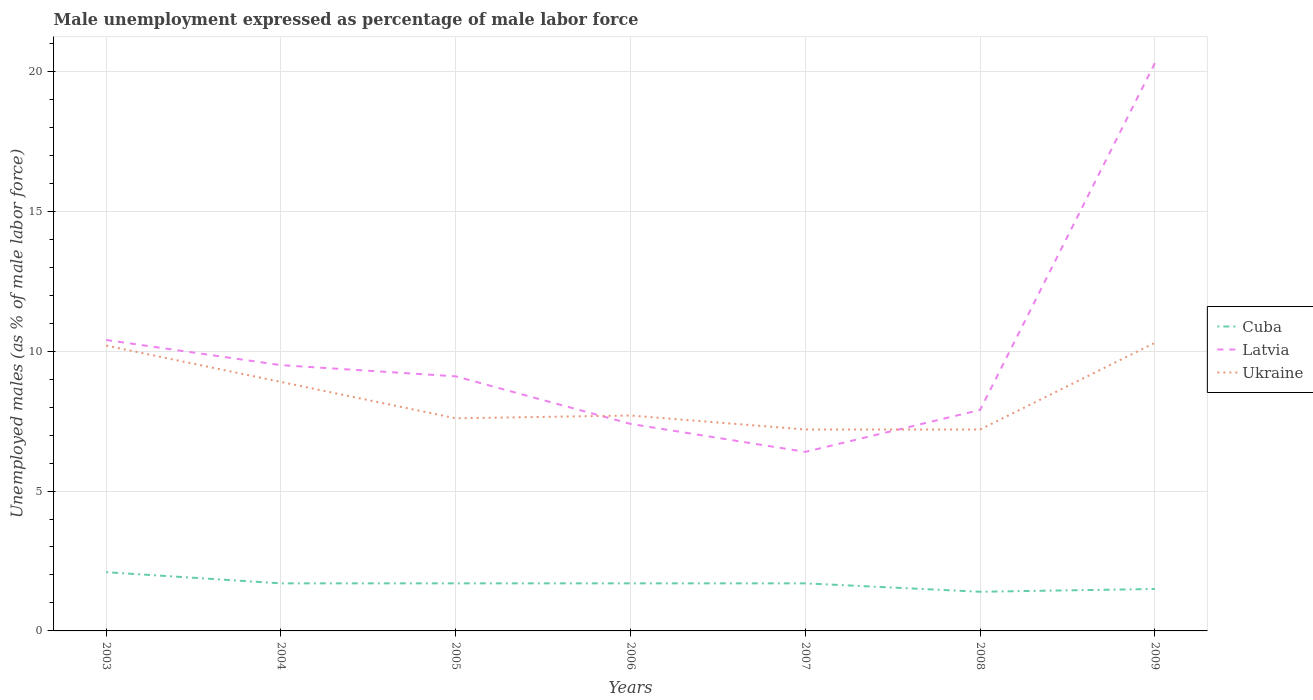Does the line corresponding to Cuba intersect with the line corresponding to Latvia?
Offer a terse response. No. Across all years, what is the maximum unemployment in males in in Ukraine?
Keep it short and to the point. 7.2. What is the total unemployment in males in in Latvia in the graph?
Keep it short and to the point. 1. What is the difference between the highest and the second highest unemployment in males in in Latvia?
Give a very brief answer. 13.9. How many lines are there?
Offer a very short reply. 3. Are the values on the major ticks of Y-axis written in scientific E-notation?
Provide a short and direct response. No. Where does the legend appear in the graph?
Offer a terse response. Center right. How many legend labels are there?
Your answer should be very brief. 3. How are the legend labels stacked?
Your answer should be compact. Vertical. What is the title of the graph?
Your answer should be very brief. Male unemployment expressed as percentage of male labor force. Does "Chile" appear as one of the legend labels in the graph?
Ensure brevity in your answer.  No. What is the label or title of the X-axis?
Offer a terse response. Years. What is the label or title of the Y-axis?
Offer a very short reply. Unemployed males (as % of male labor force). What is the Unemployed males (as % of male labor force) in Cuba in 2003?
Make the answer very short. 2.1. What is the Unemployed males (as % of male labor force) in Latvia in 2003?
Your answer should be very brief. 10.4. What is the Unemployed males (as % of male labor force) in Ukraine in 2003?
Offer a terse response. 10.2. What is the Unemployed males (as % of male labor force) of Cuba in 2004?
Your response must be concise. 1.7. What is the Unemployed males (as % of male labor force) in Ukraine in 2004?
Give a very brief answer. 8.9. What is the Unemployed males (as % of male labor force) of Cuba in 2005?
Provide a succinct answer. 1.7. What is the Unemployed males (as % of male labor force) in Latvia in 2005?
Your answer should be very brief. 9.1. What is the Unemployed males (as % of male labor force) in Ukraine in 2005?
Make the answer very short. 7.6. What is the Unemployed males (as % of male labor force) in Cuba in 2006?
Provide a short and direct response. 1.7. What is the Unemployed males (as % of male labor force) of Latvia in 2006?
Make the answer very short. 7.4. What is the Unemployed males (as % of male labor force) of Ukraine in 2006?
Offer a very short reply. 7.7. What is the Unemployed males (as % of male labor force) of Cuba in 2007?
Your response must be concise. 1.7. What is the Unemployed males (as % of male labor force) of Latvia in 2007?
Provide a succinct answer. 6.4. What is the Unemployed males (as % of male labor force) in Ukraine in 2007?
Offer a terse response. 7.2. What is the Unemployed males (as % of male labor force) of Cuba in 2008?
Your answer should be very brief. 1.4. What is the Unemployed males (as % of male labor force) of Latvia in 2008?
Your response must be concise. 7.9. What is the Unemployed males (as % of male labor force) in Ukraine in 2008?
Your answer should be very brief. 7.2. What is the Unemployed males (as % of male labor force) in Cuba in 2009?
Your answer should be compact. 1.5. What is the Unemployed males (as % of male labor force) in Latvia in 2009?
Ensure brevity in your answer.  20.3. What is the Unemployed males (as % of male labor force) in Ukraine in 2009?
Ensure brevity in your answer.  10.3. Across all years, what is the maximum Unemployed males (as % of male labor force) of Cuba?
Make the answer very short. 2.1. Across all years, what is the maximum Unemployed males (as % of male labor force) in Latvia?
Offer a very short reply. 20.3. Across all years, what is the maximum Unemployed males (as % of male labor force) of Ukraine?
Keep it short and to the point. 10.3. Across all years, what is the minimum Unemployed males (as % of male labor force) of Cuba?
Your response must be concise. 1.4. Across all years, what is the minimum Unemployed males (as % of male labor force) of Latvia?
Provide a succinct answer. 6.4. Across all years, what is the minimum Unemployed males (as % of male labor force) of Ukraine?
Provide a succinct answer. 7.2. What is the total Unemployed males (as % of male labor force) in Latvia in the graph?
Keep it short and to the point. 71. What is the total Unemployed males (as % of male labor force) in Ukraine in the graph?
Give a very brief answer. 59.1. What is the difference between the Unemployed males (as % of male labor force) in Ukraine in 2003 and that in 2004?
Your answer should be compact. 1.3. What is the difference between the Unemployed males (as % of male labor force) of Cuba in 2003 and that in 2005?
Your answer should be compact. 0.4. What is the difference between the Unemployed males (as % of male labor force) of Latvia in 2003 and that in 2005?
Your answer should be compact. 1.3. What is the difference between the Unemployed males (as % of male labor force) of Ukraine in 2003 and that in 2005?
Make the answer very short. 2.6. What is the difference between the Unemployed males (as % of male labor force) of Latvia in 2003 and that in 2006?
Your response must be concise. 3. What is the difference between the Unemployed males (as % of male labor force) in Latvia in 2003 and that in 2007?
Provide a succinct answer. 4. What is the difference between the Unemployed males (as % of male labor force) in Ukraine in 2003 and that in 2007?
Provide a succinct answer. 3. What is the difference between the Unemployed males (as % of male labor force) in Ukraine in 2003 and that in 2008?
Keep it short and to the point. 3. What is the difference between the Unemployed males (as % of male labor force) in Latvia in 2003 and that in 2009?
Your answer should be very brief. -9.9. What is the difference between the Unemployed males (as % of male labor force) in Ukraine in 2003 and that in 2009?
Give a very brief answer. -0.1. What is the difference between the Unemployed males (as % of male labor force) of Cuba in 2004 and that in 2005?
Give a very brief answer. 0. What is the difference between the Unemployed males (as % of male labor force) of Ukraine in 2004 and that in 2005?
Provide a succinct answer. 1.3. What is the difference between the Unemployed males (as % of male labor force) of Cuba in 2004 and that in 2006?
Ensure brevity in your answer.  0. What is the difference between the Unemployed males (as % of male labor force) of Cuba in 2004 and that in 2007?
Your answer should be compact. 0. What is the difference between the Unemployed males (as % of male labor force) of Ukraine in 2004 and that in 2007?
Offer a very short reply. 1.7. What is the difference between the Unemployed males (as % of male labor force) of Latvia in 2004 and that in 2008?
Provide a short and direct response. 1.6. What is the difference between the Unemployed males (as % of male labor force) in Cuba in 2004 and that in 2009?
Ensure brevity in your answer.  0.2. What is the difference between the Unemployed males (as % of male labor force) of Ukraine in 2004 and that in 2009?
Provide a short and direct response. -1.4. What is the difference between the Unemployed males (as % of male labor force) of Ukraine in 2005 and that in 2007?
Offer a terse response. 0.4. What is the difference between the Unemployed males (as % of male labor force) in Cuba in 2005 and that in 2008?
Make the answer very short. 0.3. What is the difference between the Unemployed males (as % of male labor force) in Latvia in 2005 and that in 2008?
Give a very brief answer. 1.2. What is the difference between the Unemployed males (as % of male labor force) in Ukraine in 2005 and that in 2008?
Provide a succinct answer. 0.4. What is the difference between the Unemployed males (as % of male labor force) of Cuba in 2005 and that in 2009?
Offer a very short reply. 0.2. What is the difference between the Unemployed males (as % of male labor force) in Ukraine in 2007 and that in 2008?
Offer a very short reply. 0. What is the difference between the Unemployed males (as % of male labor force) in Cuba in 2007 and that in 2009?
Your answer should be very brief. 0.2. What is the difference between the Unemployed males (as % of male labor force) of Latvia in 2007 and that in 2009?
Keep it short and to the point. -13.9. What is the difference between the Unemployed males (as % of male labor force) of Ukraine in 2007 and that in 2009?
Your answer should be very brief. -3.1. What is the difference between the Unemployed males (as % of male labor force) in Cuba in 2008 and that in 2009?
Your answer should be very brief. -0.1. What is the difference between the Unemployed males (as % of male labor force) in Latvia in 2008 and that in 2009?
Ensure brevity in your answer.  -12.4. What is the difference between the Unemployed males (as % of male labor force) in Latvia in 2003 and the Unemployed males (as % of male labor force) in Ukraine in 2004?
Provide a succinct answer. 1.5. What is the difference between the Unemployed males (as % of male labor force) of Latvia in 2003 and the Unemployed males (as % of male labor force) of Ukraine in 2005?
Give a very brief answer. 2.8. What is the difference between the Unemployed males (as % of male labor force) of Cuba in 2003 and the Unemployed males (as % of male labor force) of Latvia in 2006?
Keep it short and to the point. -5.3. What is the difference between the Unemployed males (as % of male labor force) in Cuba in 2003 and the Unemployed males (as % of male labor force) in Ukraine in 2006?
Your answer should be compact. -5.6. What is the difference between the Unemployed males (as % of male labor force) in Latvia in 2003 and the Unemployed males (as % of male labor force) in Ukraine in 2006?
Offer a terse response. 2.7. What is the difference between the Unemployed males (as % of male labor force) of Cuba in 2003 and the Unemployed males (as % of male labor force) of Latvia in 2008?
Make the answer very short. -5.8. What is the difference between the Unemployed males (as % of male labor force) of Cuba in 2003 and the Unemployed males (as % of male labor force) of Latvia in 2009?
Offer a terse response. -18.2. What is the difference between the Unemployed males (as % of male labor force) of Latvia in 2003 and the Unemployed males (as % of male labor force) of Ukraine in 2009?
Make the answer very short. 0.1. What is the difference between the Unemployed males (as % of male labor force) of Cuba in 2004 and the Unemployed males (as % of male labor force) of Ukraine in 2005?
Ensure brevity in your answer.  -5.9. What is the difference between the Unemployed males (as % of male labor force) of Latvia in 2004 and the Unemployed males (as % of male labor force) of Ukraine in 2005?
Your answer should be compact. 1.9. What is the difference between the Unemployed males (as % of male labor force) in Cuba in 2004 and the Unemployed males (as % of male labor force) in Latvia in 2006?
Provide a short and direct response. -5.7. What is the difference between the Unemployed males (as % of male labor force) in Latvia in 2004 and the Unemployed males (as % of male labor force) in Ukraine in 2007?
Give a very brief answer. 2.3. What is the difference between the Unemployed males (as % of male labor force) of Cuba in 2004 and the Unemployed males (as % of male labor force) of Latvia in 2008?
Keep it short and to the point. -6.2. What is the difference between the Unemployed males (as % of male labor force) in Cuba in 2004 and the Unemployed males (as % of male labor force) in Latvia in 2009?
Make the answer very short. -18.6. What is the difference between the Unemployed males (as % of male labor force) in Cuba in 2005 and the Unemployed males (as % of male labor force) in Latvia in 2006?
Provide a succinct answer. -5.7. What is the difference between the Unemployed males (as % of male labor force) of Latvia in 2005 and the Unemployed males (as % of male labor force) of Ukraine in 2006?
Your answer should be very brief. 1.4. What is the difference between the Unemployed males (as % of male labor force) in Cuba in 2005 and the Unemployed males (as % of male labor force) in Latvia in 2007?
Your answer should be compact. -4.7. What is the difference between the Unemployed males (as % of male labor force) of Cuba in 2005 and the Unemployed males (as % of male labor force) of Ukraine in 2007?
Give a very brief answer. -5.5. What is the difference between the Unemployed males (as % of male labor force) of Cuba in 2005 and the Unemployed males (as % of male labor force) of Latvia in 2008?
Provide a succinct answer. -6.2. What is the difference between the Unemployed males (as % of male labor force) of Cuba in 2005 and the Unemployed males (as % of male labor force) of Ukraine in 2008?
Your answer should be compact. -5.5. What is the difference between the Unemployed males (as % of male labor force) in Latvia in 2005 and the Unemployed males (as % of male labor force) in Ukraine in 2008?
Keep it short and to the point. 1.9. What is the difference between the Unemployed males (as % of male labor force) in Cuba in 2005 and the Unemployed males (as % of male labor force) in Latvia in 2009?
Provide a succinct answer. -18.6. What is the difference between the Unemployed males (as % of male labor force) of Latvia in 2005 and the Unemployed males (as % of male labor force) of Ukraine in 2009?
Provide a succinct answer. -1.2. What is the difference between the Unemployed males (as % of male labor force) of Cuba in 2006 and the Unemployed males (as % of male labor force) of Latvia in 2007?
Keep it short and to the point. -4.7. What is the difference between the Unemployed males (as % of male labor force) in Cuba in 2006 and the Unemployed males (as % of male labor force) in Ukraine in 2008?
Give a very brief answer. -5.5. What is the difference between the Unemployed males (as % of male labor force) in Cuba in 2006 and the Unemployed males (as % of male labor force) in Latvia in 2009?
Make the answer very short. -18.6. What is the difference between the Unemployed males (as % of male labor force) in Cuba in 2007 and the Unemployed males (as % of male labor force) in Latvia in 2008?
Provide a succinct answer. -6.2. What is the difference between the Unemployed males (as % of male labor force) in Cuba in 2007 and the Unemployed males (as % of male labor force) in Ukraine in 2008?
Your response must be concise. -5.5. What is the difference between the Unemployed males (as % of male labor force) of Cuba in 2007 and the Unemployed males (as % of male labor force) of Latvia in 2009?
Provide a succinct answer. -18.6. What is the difference between the Unemployed males (as % of male labor force) in Latvia in 2007 and the Unemployed males (as % of male labor force) in Ukraine in 2009?
Ensure brevity in your answer.  -3.9. What is the difference between the Unemployed males (as % of male labor force) in Cuba in 2008 and the Unemployed males (as % of male labor force) in Latvia in 2009?
Provide a short and direct response. -18.9. What is the difference between the Unemployed males (as % of male labor force) in Cuba in 2008 and the Unemployed males (as % of male labor force) in Ukraine in 2009?
Make the answer very short. -8.9. What is the average Unemployed males (as % of male labor force) of Cuba per year?
Provide a short and direct response. 1.69. What is the average Unemployed males (as % of male labor force) of Latvia per year?
Make the answer very short. 10.14. What is the average Unemployed males (as % of male labor force) of Ukraine per year?
Give a very brief answer. 8.44. In the year 2003, what is the difference between the Unemployed males (as % of male labor force) of Cuba and Unemployed males (as % of male labor force) of Latvia?
Offer a very short reply. -8.3. In the year 2003, what is the difference between the Unemployed males (as % of male labor force) of Latvia and Unemployed males (as % of male labor force) of Ukraine?
Make the answer very short. 0.2. In the year 2004, what is the difference between the Unemployed males (as % of male labor force) in Cuba and Unemployed males (as % of male labor force) in Latvia?
Your answer should be very brief. -7.8. In the year 2004, what is the difference between the Unemployed males (as % of male labor force) in Cuba and Unemployed males (as % of male labor force) in Ukraine?
Ensure brevity in your answer.  -7.2. In the year 2004, what is the difference between the Unemployed males (as % of male labor force) of Latvia and Unemployed males (as % of male labor force) of Ukraine?
Offer a terse response. 0.6. In the year 2005, what is the difference between the Unemployed males (as % of male labor force) of Cuba and Unemployed males (as % of male labor force) of Ukraine?
Your response must be concise. -5.9. In the year 2005, what is the difference between the Unemployed males (as % of male labor force) in Latvia and Unemployed males (as % of male labor force) in Ukraine?
Offer a terse response. 1.5. In the year 2006, what is the difference between the Unemployed males (as % of male labor force) of Cuba and Unemployed males (as % of male labor force) of Ukraine?
Provide a short and direct response. -6. In the year 2006, what is the difference between the Unemployed males (as % of male labor force) of Latvia and Unemployed males (as % of male labor force) of Ukraine?
Your response must be concise. -0.3. In the year 2007, what is the difference between the Unemployed males (as % of male labor force) in Cuba and Unemployed males (as % of male labor force) in Latvia?
Ensure brevity in your answer.  -4.7. In the year 2007, what is the difference between the Unemployed males (as % of male labor force) in Cuba and Unemployed males (as % of male labor force) in Ukraine?
Provide a succinct answer. -5.5. In the year 2008, what is the difference between the Unemployed males (as % of male labor force) of Cuba and Unemployed males (as % of male labor force) of Ukraine?
Make the answer very short. -5.8. In the year 2008, what is the difference between the Unemployed males (as % of male labor force) in Latvia and Unemployed males (as % of male labor force) in Ukraine?
Give a very brief answer. 0.7. In the year 2009, what is the difference between the Unemployed males (as % of male labor force) of Cuba and Unemployed males (as % of male labor force) of Latvia?
Your answer should be compact. -18.8. In the year 2009, what is the difference between the Unemployed males (as % of male labor force) of Latvia and Unemployed males (as % of male labor force) of Ukraine?
Your answer should be compact. 10. What is the ratio of the Unemployed males (as % of male labor force) in Cuba in 2003 to that in 2004?
Offer a very short reply. 1.24. What is the ratio of the Unemployed males (as % of male labor force) in Latvia in 2003 to that in 2004?
Give a very brief answer. 1.09. What is the ratio of the Unemployed males (as % of male labor force) in Ukraine in 2003 to that in 2004?
Your answer should be very brief. 1.15. What is the ratio of the Unemployed males (as % of male labor force) in Cuba in 2003 to that in 2005?
Your answer should be very brief. 1.24. What is the ratio of the Unemployed males (as % of male labor force) of Ukraine in 2003 to that in 2005?
Keep it short and to the point. 1.34. What is the ratio of the Unemployed males (as % of male labor force) of Cuba in 2003 to that in 2006?
Provide a short and direct response. 1.24. What is the ratio of the Unemployed males (as % of male labor force) of Latvia in 2003 to that in 2006?
Ensure brevity in your answer.  1.41. What is the ratio of the Unemployed males (as % of male labor force) of Ukraine in 2003 to that in 2006?
Provide a short and direct response. 1.32. What is the ratio of the Unemployed males (as % of male labor force) of Cuba in 2003 to that in 2007?
Your answer should be very brief. 1.24. What is the ratio of the Unemployed males (as % of male labor force) of Latvia in 2003 to that in 2007?
Offer a terse response. 1.62. What is the ratio of the Unemployed males (as % of male labor force) in Ukraine in 2003 to that in 2007?
Ensure brevity in your answer.  1.42. What is the ratio of the Unemployed males (as % of male labor force) in Cuba in 2003 to that in 2008?
Make the answer very short. 1.5. What is the ratio of the Unemployed males (as % of male labor force) of Latvia in 2003 to that in 2008?
Offer a terse response. 1.32. What is the ratio of the Unemployed males (as % of male labor force) of Ukraine in 2003 to that in 2008?
Give a very brief answer. 1.42. What is the ratio of the Unemployed males (as % of male labor force) of Latvia in 2003 to that in 2009?
Give a very brief answer. 0.51. What is the ratio of the Unemployed males (as % of male labor force) of Ukraine in 2003 to that in 2009?
Offer a terse response. 0.99. What is the ratio of the Unemployed males (as % of male labor force) in Cuba in 2004 to that in 2005?
Your answer should be compact. 1. What is the ratio of the Unemployed males (as % of male labor force) in Latvia in 2004 to that in 2005?
Give a very brief answer. 1.04. What is the ratio of the Unemployed males (as % of male labor force) in Ukraine in 2004 to that in 2005?
Your response must be concise. 1.17. What is the ratio of the Unemployed males (as % of male labor force) in Cuba in 2004 to that in 2006?
Your answer should be compact. 1. What is the ratio of the Unemployed males (as % of male labor force) in Latvia in 2004 to that in 2006?
Provide a succinct answer. 1.28. What is the ratio of the Unemployed males (as % of male labor force) of Ukraine in 2004 to that in 2006?
Offer a terse response. 1.16. What is the ratio of the Unemployed males (as % of male labor force) in Latvia in 2004 to that in 2007?
Provide a short and direct response. 1.48. What is the ratio of the Unemployed males (as % of male labor force) in Ukraine in 2004 to that in 2007?
Your answer should be very brief. 1.24. What is the ratio of the Unemployed males (as % of male labor force) of Cuba in 2004 to that in 2008?
Make the answer very short. 1.21. What is the ratio of the Unemployed males (as % of male labor force) of Latvia in 2004 to that in 2008?
Keep it short and to the point. 1.2. What is the ratio of the Unemployed males (as % of male labor force) in Ukraine in 2004 to that in 2008?
Ensure brevity in your answer.  1.24. What is the ratio of the Unemployed males (as % of male labor force) of Cuba in 2004 to that in 2009?
Your answer should be very brief. 1.13. What is the ratio of the Unemployed males (as % of male labor force) in Latvia in 2004 to that in 2009?
Provide a short and direct response. 0.47. What is the ratio of the Unemployed males (as % of male labor force) in Ukraine in 2004 to that in 2009?
Give a very brief answer. 0.86. What is the ratio of the Unemployed males (as % of male labor force) in Cuba in 2005 to that in 2006?
Your answer should be very brief. 1. What is the ratio of the Unemployed males (as % of male labor force) in Latvia in 2005 to that in 2006?
Your answer should be very brief. 1.23. What is the ratio of the Unemployed males (as % of male labor force) in Ukraine in 2005 to that in 2006?
Provide a short and direct response. 0.99. What is the ratio of the Unemployed males (as % of male labor force) in Cuba in 2005 to that in 2007?
Your response must be concise. 1. What is the ratio of the Unemployed males (as % of male labor force) in Latvia in 2005 to that in 2007?
Provide a succinct answer. 1.42. What is the ratio of the Unemployed males (as % of male labor force) of Ukraine in 2005 to that in 2007?
Your response must be concise. 1.06. What is the ratio of the Unemployed males (as % of male labor force) in Cuba in 2005 to that in 2008?
Make the answer very short. 1.21. What is the ratio of the Unemployed males (as % of male labor force) of Latvia in 2005 to that in 2008?
Provide a succinct answer. 1.15. What is the ratio of the Unemployed males (as % of male labor force) in Ukraine in 2005 to that in 2008?
Your response must be concise. 1.06. What is the ratio of the Unemployed males (as % of male labor force) in Cuba in 2005 to that in 2009?
Provide a succinct answer. 1.13. What is the ratio of the Unemployed males (as % of male labor force) of Latvia in 2005 to that in 2009?
Your answer should be compact. 0.45. What is the ratio of the Unemployed males (as % of male labor force) of Ukraine in 2005 to that in 2009?
Provide a succinct answer. 0.74. What is the ratio of the Unemployed males (as % of male labor force) in Cuba in 2006 to that in 2007?
Ensure brevity in your answer.  1. What is the ratio of the Unemployed males (as % of male labor force) of Latvia in 2006 to that in 2007?
Your answer should be compact. 1.16. What is the ratio of the Unemployed males (as % of male labor force) in Ukraine in 2006 to that in 2007?
Ensure brevity in your answer.  1.07. What is the ratio of the Unemployed males (as % of male labor force) of Cuba in 2006 to that in 2008?
Your answer should be compact. 1.21. What is the ratio of the Unemployed males (as % of male labor force) in Latvia in 2006 to that in 2008?
Your answer should be compact. 0.94. What is the ratio of the Unemployed males (as % of male labor force) in Ukraine in 2006 to that in 2008?
Make the answer very short. 1.07. What is the ratio of the Unemployed males (as % of male labor force) in Cuba in 2006 to that in 2009?
Provide a short and direct response. 1.13. What is the ratio of the Unemployed males (as % of male labor force) in Latvia in 2006 to that in 2009?
Your answer should be very brief. 0.36. What is the ratio of the Unemployed males (as % of male labor force) of Ukraine in 2006 to that in 2009?
Offer a very short reply. 0.75. What is the ratio of the Unemployed males (as % of male labor force) in Cuba in 2007 to that in 2008?
Provide a short and direct response. 1.21. What is the ratio of the Unemployed males (as % of male labor force) in Latvia in 2007 to that in 2008?
Make the answer very short. 0.81. What is the ratio of the Unemployed males (as % of male labor force) of Ukraine in 2007 to that in 2008?
Your answer should be compact. 1. What is the ratio of the Unemployed males (as % of male labor force) in Cuba in 2007 to that in 2009?
Provide a short and direct response. 1.13. What is the ratio of the Unemployed males (as % of male labor force) of Latvia in 2007 to that in 2009?
Provide a short and direct response. 0.32. What is the ratio of the Unemployed males (as % of male labor force) in Ukraine in 2007 to that in 2009?
Give a very brief answer. 0.7. What is the ratio of the Unemployed males (as % of male labor force) of Latvia in 2008 to that in 2009?
Your answer should be compact. 0.39. What is the ratio of the Unemployed males (as % of male labor force) in Ukraine in 2008 to that in 2009?
Give a very brief answer. 0.7. What is the difference between the highest and the second highest Unemployed males (as % of male labor force) in Cuba?
Your response must be concise. 0.4. What is the difference between the highest and the second highest Unemployed males (as % of male labor force) of Latvia?
Your answer should be compact. 9.9. What is the difference between the highest and the lowest Unemployed males (as % of male labor force) of Ukraine?
Give a very brief answer. 3.1. 